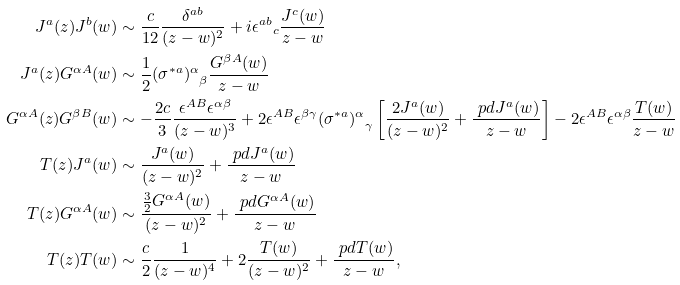Convert formula to latex. <formula><loc_0><loc_0><loc_500><loc_500>J ^ { a } ( z ) J ^ { b } ( w ) & \sim \frac { c } { 1 2 } \frac { \delta ^ { a b } } { ( z - w ) ^ { 2 } } + i { \epsilon ^ { a b } } _ { c } \frac { J ^ { c } ( w ) } { z - w } \\ J ^ { a } ( z ) G ^ { \alpha A } ( w ) & \sim \frac { 1 } { 2 } { ( \sigma ^ { * a } ) ^ { \alpha } } _ { \beta } \frac { G ^ { \beta A } ( w ) } { z - w } \\ G ^ { \alpha A } ( z ) G ^ { \beta B } ( w ) & \sim - \frac { 2 c } { 3 } \frac { \epsilon ^ { A B } \epsilon ^ { \alpha \beta } } { ( z - w ) ^ { 3 } } + 2 \epsilon ^ { A B } \epsilon ^ { \beta \gamma } { ( \sigma ^ { * a } ) ^ { \alpha } } _ { \gamma } \left [ \frac { 2 J ^ { a } ( w ) } { ( z - w ) ^ { 2 } } + \frac { \ p d J ^ { a } ( w ) } { z - w } \right ] - 2 \epsilon ^ { A B } \epsilon ^ { \alpha \beta } \frac { T ( w ) } { z - w } \\ T ( z ) J ^ { a } ( w ) & \sim \frac { J ^ { a } ( w ) } { ( z - w ) ^ { 2 } } + \frac { \ p d J ^ { a } ( w ) } { z - w } \\ T ( z ) G ^ { \alpha A } ( w ) & \sim \frac { \frac { 3 } { 2 } G ^ { \alpha A } ( w ) } { ( z - w ) ^ { 2 } } + \frac { \ p d G ^ { \alpha A } ( w ) } { z - w } \\ T ( z ) T ( w ) & \sim \frac { c } { 2 } \frac { 1 } { ( z - w ) ^ { 4 } } + 2 \frac { T ( w ) } { ( z - w ) ^ { 2 } } + \frac { \ p d T ( w ) } { z - w } ,</formula> 